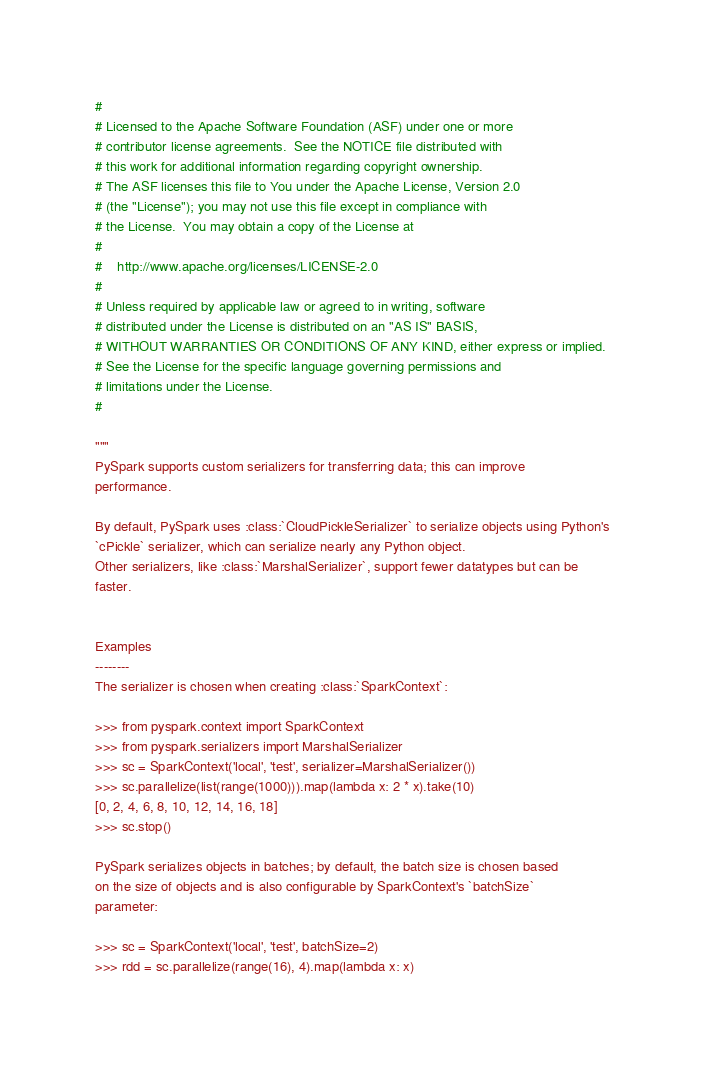<code> <loc_0><loc_0><loc_500><loc_500><_Python_>#
# Licensed to the Apache Software Foundation (ASF) under one or more
# contributor license agreements.  See the NOTICE file distributed with
# this work for additional information regarding copyright ownership.
# The ASF licenses this file to You under the Apache License, Version 2.0
# (the "License"); you may not use this file except in compliance with
# the License.  You may obtain a copy of the License at
#
#    http://www.apache.org/licenses/LICENSE-2.0
#
# Unless required by applicable law or agreed to in writing, software
# distributed under the License is distributed on an "AS IS" BASIS,
# WITHOUT WARRANTIES OR CONDITIONS OF ANY KIND, either express or implied.
# See the License for the specific language governing permissions and
# limitations under the License.
#

"""
PySpark supports custom serializers for transferring data; this can improve
performance.

By default, PySpark uses :class:`CloudPickleSerializer` to serialize objects using Python's
`cPickle` serializer, which can serialize nearly any Python object.
Other serializers, like :class:`MarshalSerializer`, support fewer datatypes but can be
faster.


Examples
--------
The serializer is chosen when creating :class:`SparkContext`:

>>> from pyspark.context import SparkContext
>>> from pyspark.serializers import MarshalSerializer
>>> sc = SparkContext('local', 'test', serializer=MarshalSerializer())
>>> sc.parallelize(list(range(1000))).map(lambda x: 2 * x).take(10)
[0, 2, 4, 6, 8, 10, 12, 14, 16, 18]
>>> sc.stop()

PySpark serializes objects in batches; by default, the batch size is chosen based
on the size of objects and is also configurable by SparkContext's `batchSize`
parameter:

>>> sc = SparkContext('local', 'test', batchSize=2)
>>> rdd = sc.parallelize(range(16), 4).map(lambda x: x)
</code> 